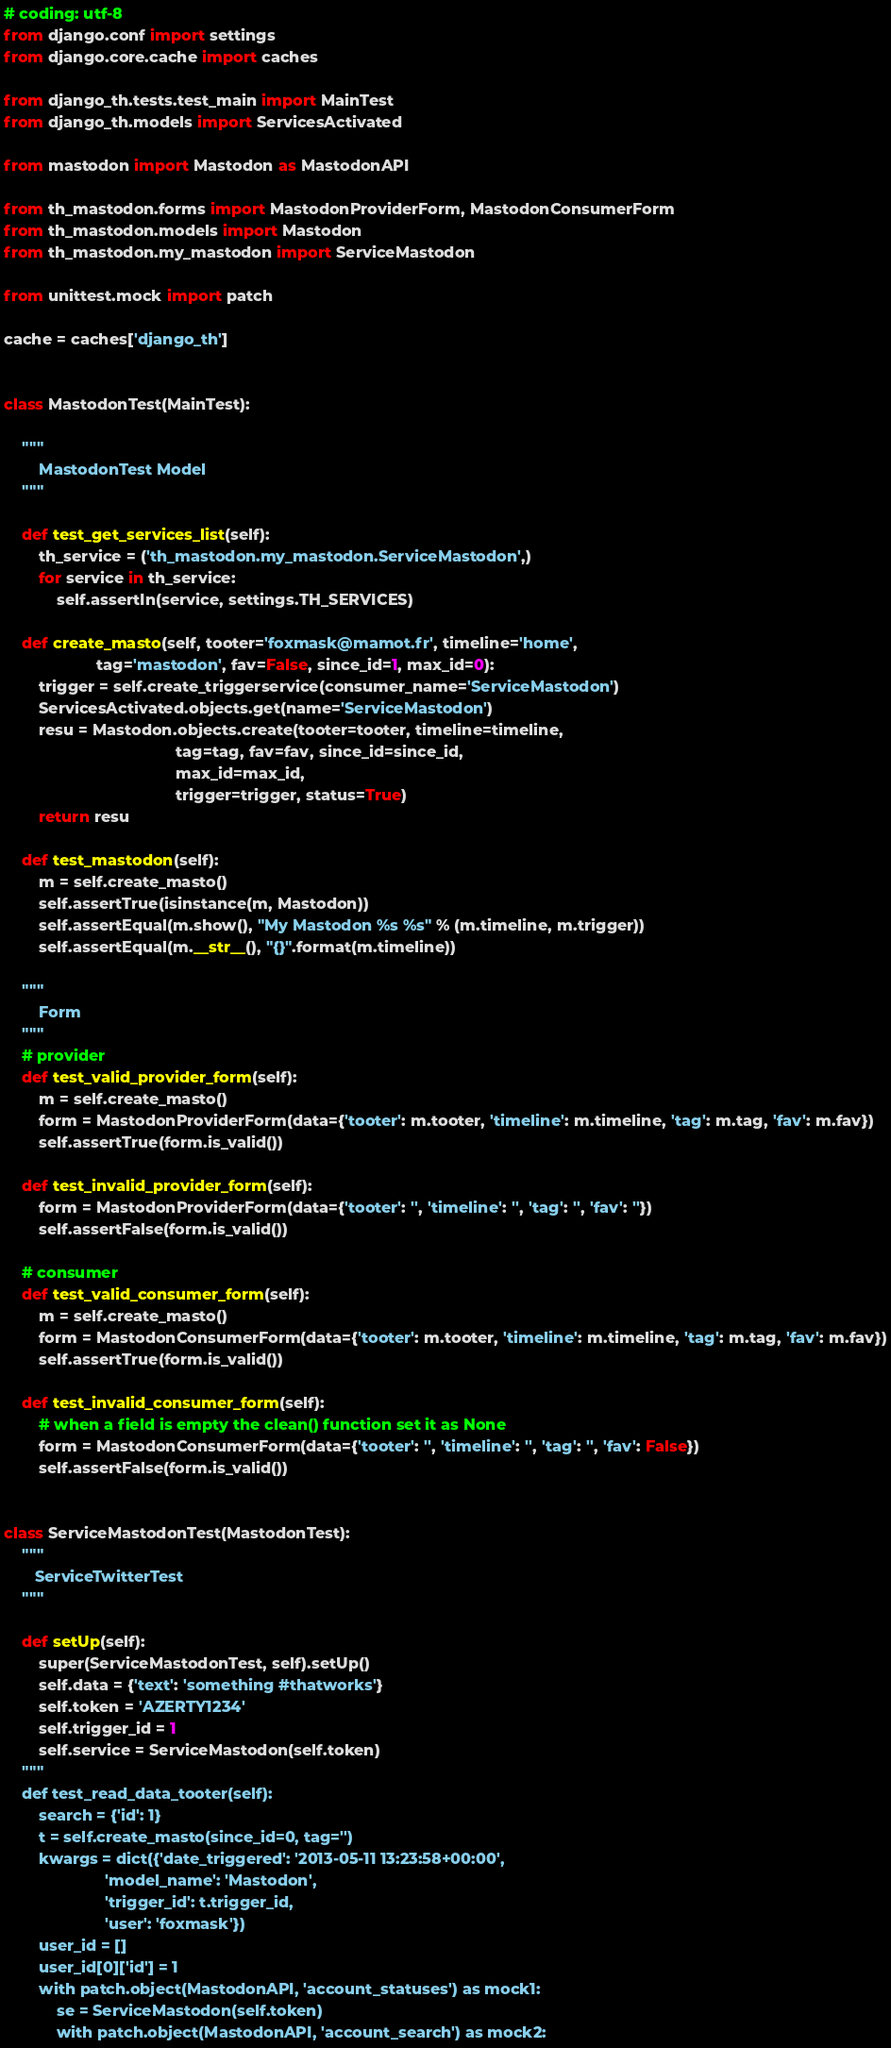<code> <loc_0><loc_0><loc_500><loc_500><_Python_># coding: utf-8
from django.conf import settings
from django.core.cache import caches

from django_th.tests.test_main import MainTest
from django_th.models import ServicesActivated

from mastodon import Mastodon as MastodonAPI

from th_mastodon.forms import MastodonProviderForm, MastodonConsumerForm
from th_mastodon.models import Mastodon
from th_mastodon.my_mastodon import ServiceMastodon

from unittest.mock import patch

cache = caches['django_th']


class MastodonTest(MainTest):

    """
        MastodonTest Model
    """

    def test_get_services_list(self):
        th_service = ('th_mastodon.my_mastodon.ServiceMastodon',)
        for service in th_service:
            self.assertIn(service, settings.TH_SERVICES)

    def create_masto(self, tooter='foxmask@mamot.fr', timeline='home',
                     tag='mastodon', fav=False, since_id=1, max_id=0):
        trigger = self.create_triggerservice(consumer_name='ServiceMastodon')
        ServicesActivated.objects.get(name='ServiceMastodon')
        resu = Mastodon.objects.create(tooter=tooter, timeline=timeline,
                                       tag=tag, fav=fav, since_id=since_id,
                                       max_id=max_id,
                                       trigger=trigger, status=True)
        return resu

    def test_mastodon(self):
        m = self.create_masto()
        self.assertTrue(isinstance(m, Mastodon))
        self.assertEqual(m.show(), "My Mastodon %s %s" % (m.timeline, m.trigger))
        self.assertEqual(m.__str__(), "{}".format(m.timeline))

    """
        Form
    """
    # provider
    def test_valid_provider_form(self):
        m = self.create_masto()
        form = MastodonProviderForm(data={'tooter': m.tooter, 'timeline': m.timeline, 'tag': m.tag, 'fav': m.fav})
        self.assertTrue(form.is_valid())

    def test_invalid_provider_form(self):
        form = MastodonProviderForm(data={'tooter': '', 'timeline': '', 'tag': '', 'fav': ''})
        self.assertFalse(form.is_valid())

    # consumer
    def test_valid_consumer_form(self):
        m = self.create_masto()
        form = MastodonConsumerForm(data={'tooter': m.tooter, 'timeline': m.timeline, 'tag': m.tag, 'fav': m.fav})
        self.assertTrue(form.is_valid())

    def test_invalid_consumer_form(self):
        # when a field is empty the clean() function set it as None
        form = MastodonConsumerForm(data={'tooter': '', 'timeline': '', 'tag': '', 'fav': False})
        self.assertFalse(form.is_valid())


class ServiceMastodonTest(MastodonTest):
    """
       ServiceTwitterTest
    """

    def setUp(self):
        super(ServiceMastodonTest, self).setUp()
        self.data = {'text': 'something #thatworks'}
        self.token = 'AZERTY1234'
        self.trigger_id = 1
        self.service = ServiceMastodon(self.token)
    """
    def test_read_data_tooter(self):
        search = {'id': 1}
        t = self.create_masto(since_id=0, tag='')
        kwargs = dict({'date_triggered': '2013-05-11 13:23:58+00:00',
                       'model_name': 'Mastodon',
                       'trigger_id': t.trigger_id,
                       'user': 'foxmask'})
        user_id = []
        user_id[0]['id'] = 1
        with patch.object(MastodonAPI, 'account_statuses') as mock1:
            se = ServiceMastodon(self.token)
            with patch.object(MastodonAPI, 'account_search') as mock2:</code> 